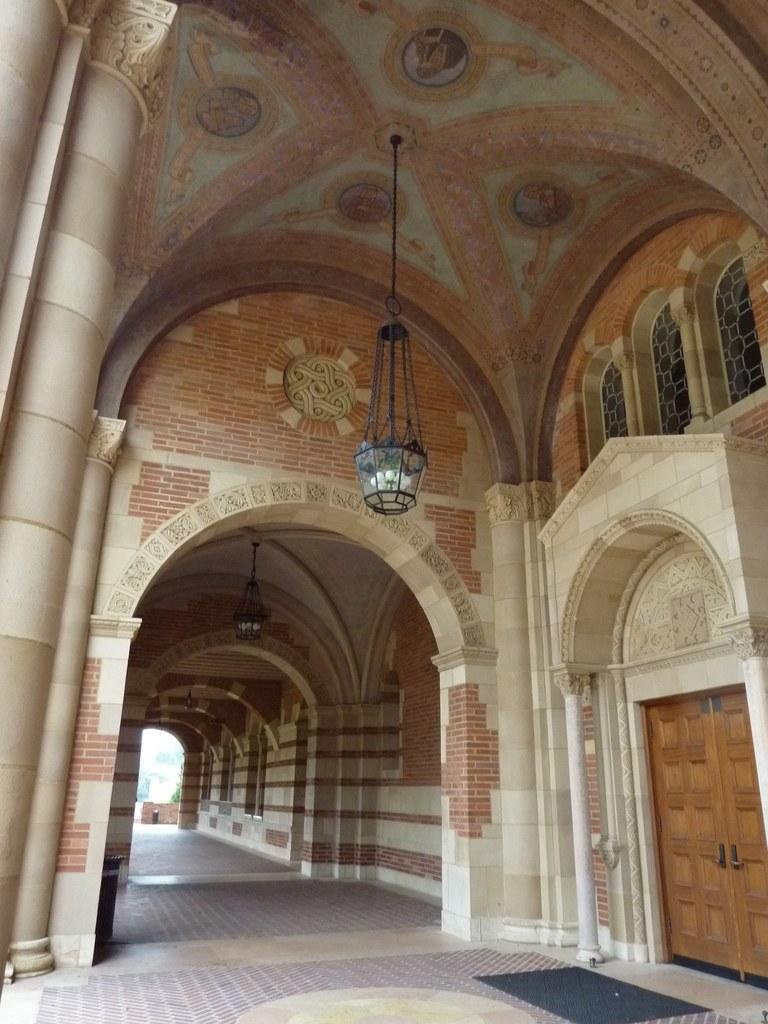What type of structure is present in the image? There is a building in the image. What can be seen illuminating the building or its surroundings? There are lights visible in the image. Are there any openings or entrances in the building? Yes, there are doors in the image. What type of cheese is being grilled on the flame in the image? There is no cheese or flame present in the image; it only features a building with lights and doors. 